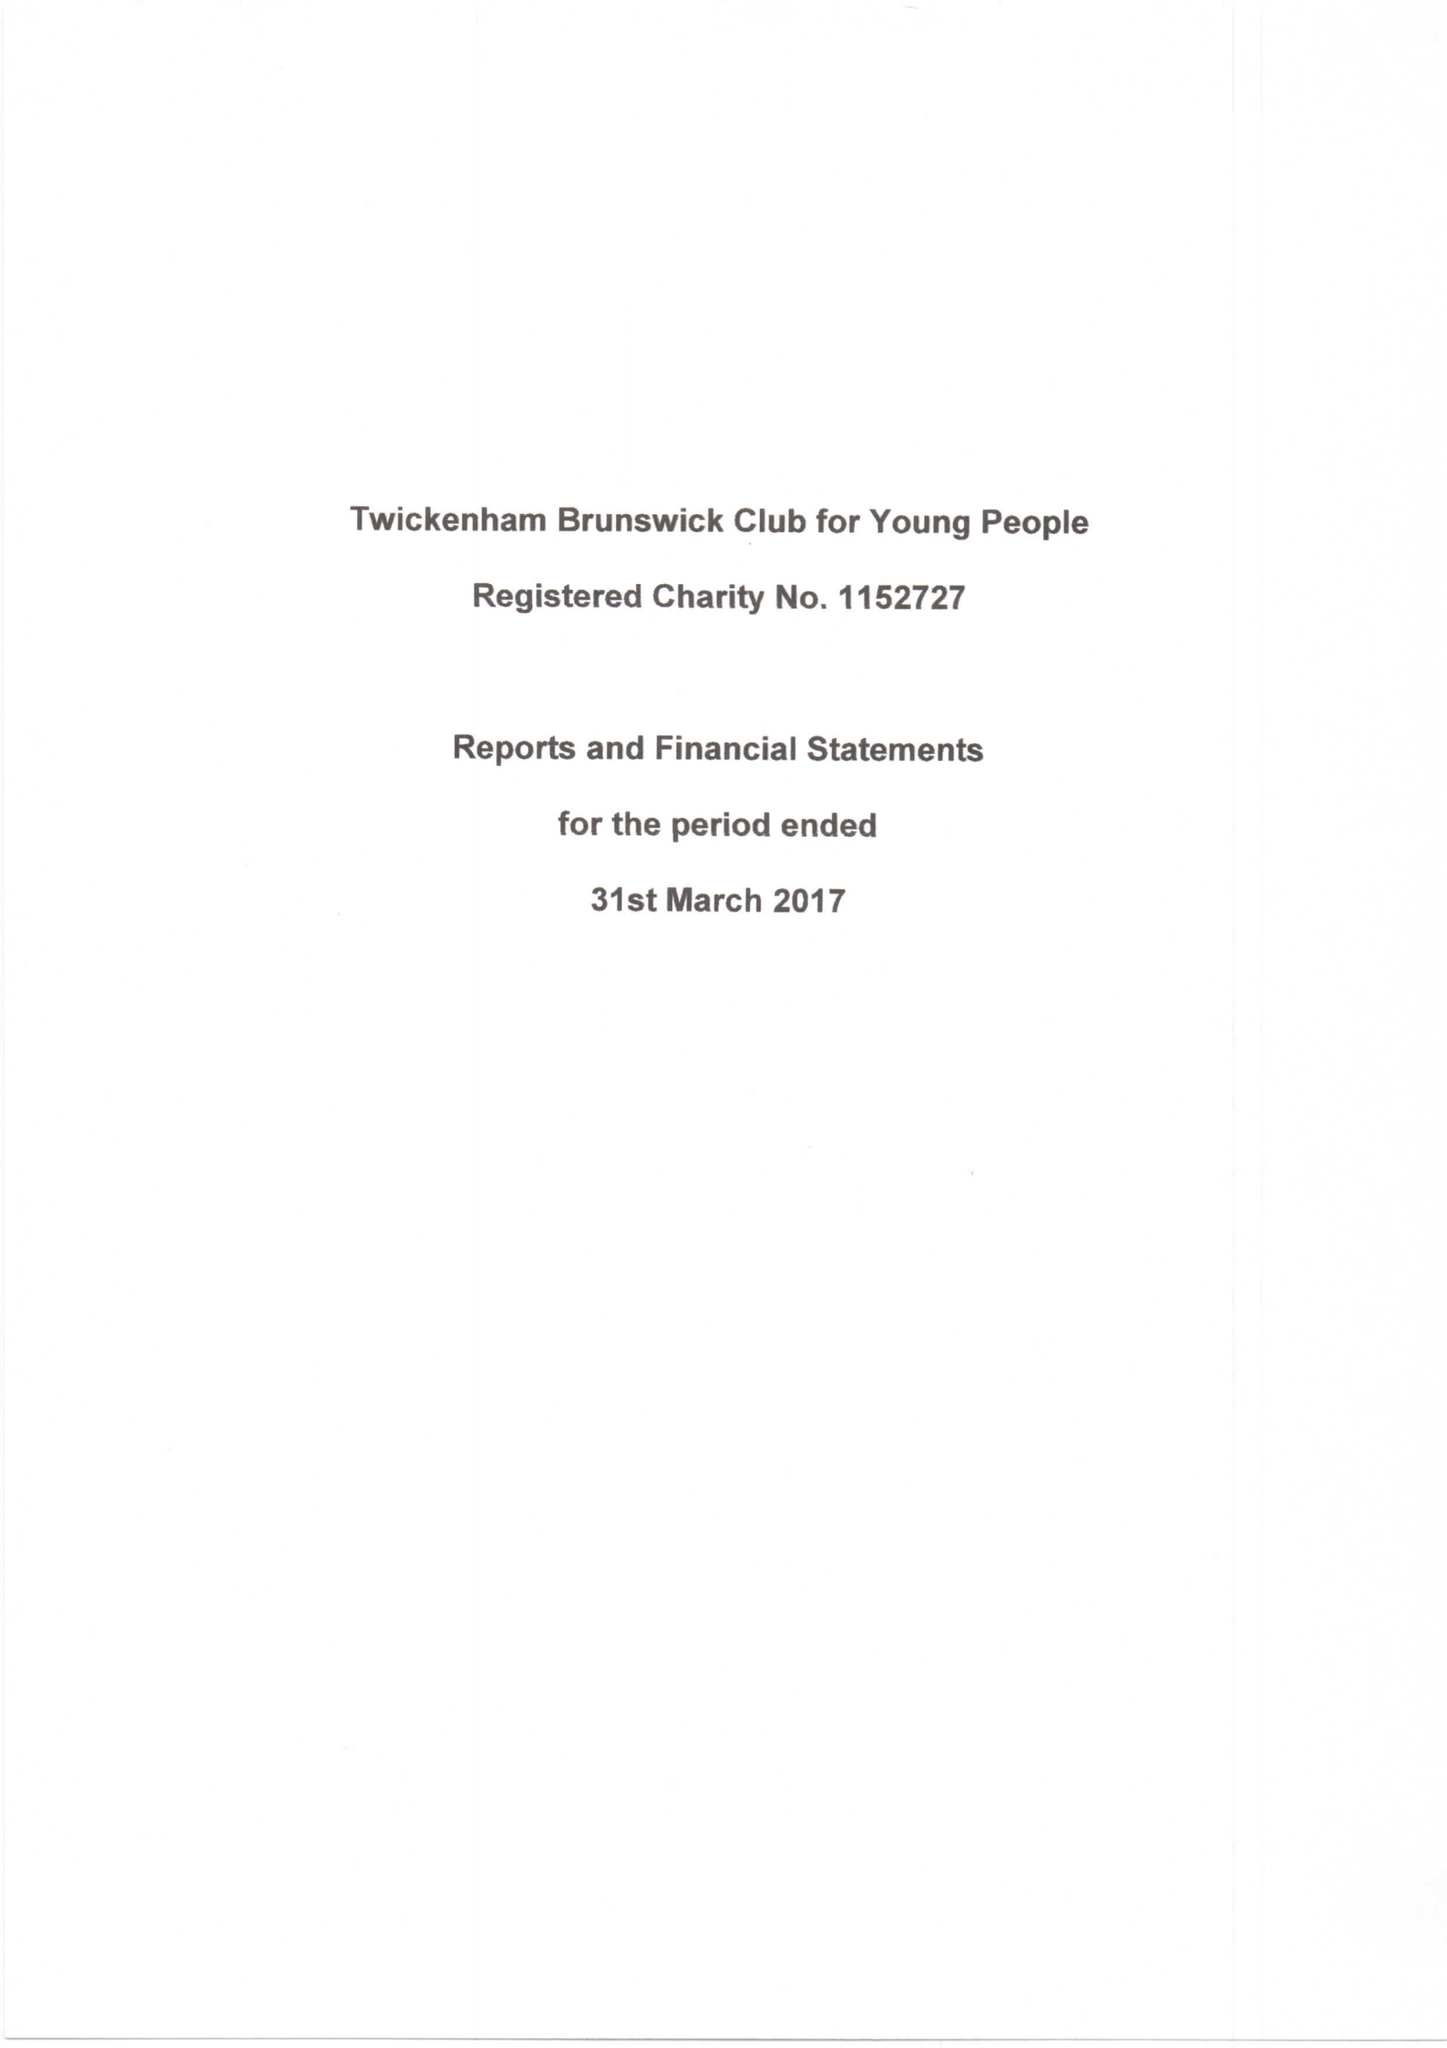What is the value for the address__post_town?
Answer the question using a single word or phrase. TWICKENHAM 